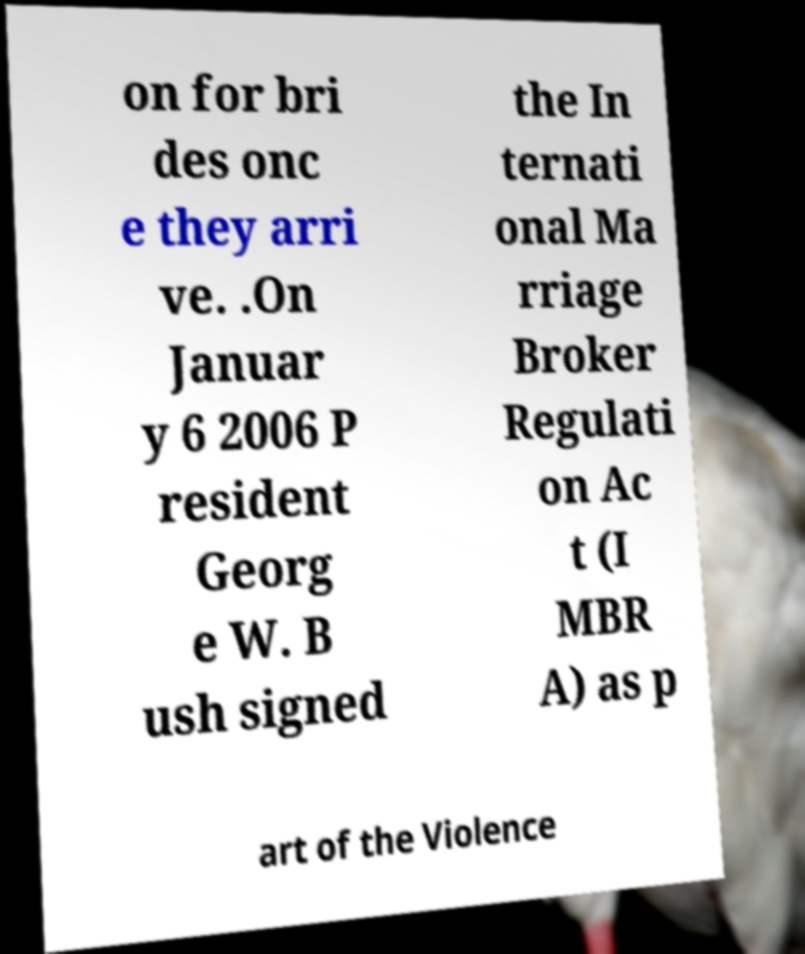Please identify and transcribe the text found in this image. on for bri des onc e they arri ve. .On Januar y 6 2006 P resident Georg e W. B ush signed the In ternati onal Ma rriage Broker Regulati on Ac t (I MBR A) as p art of the Violence 